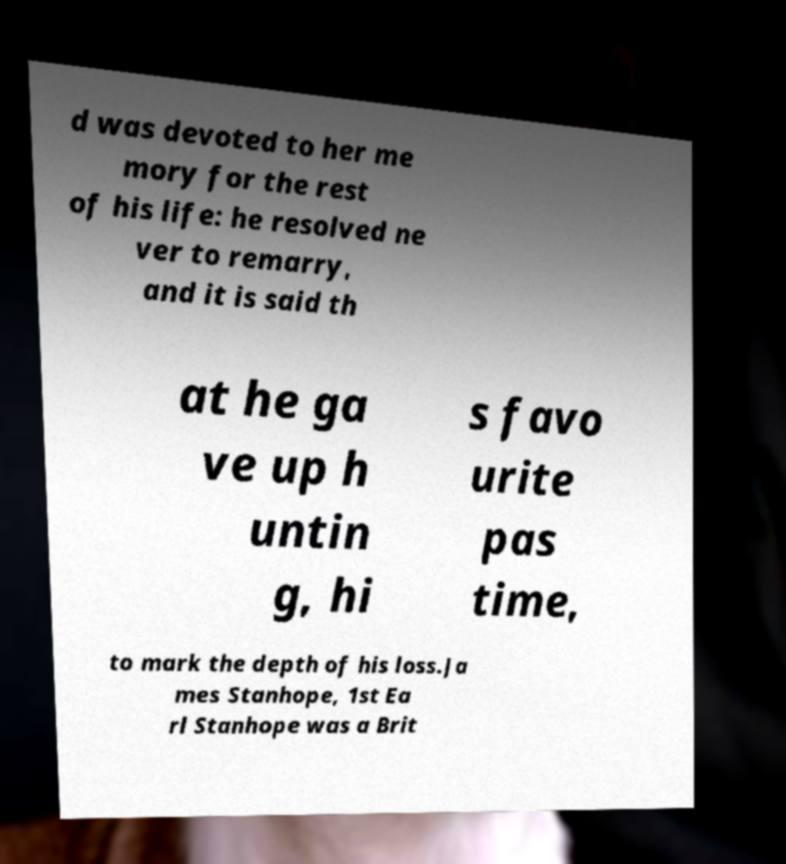For documentation purposes, I need the text within this image transcribed. Could you provide that? d was devoted to her me mory for the rest of his life: he resolved ne ver to remarry, and it is said th at he ga ve up h untin g, hi s favo urite pas time, to mark the depth of his loss.Ja mes Stanhope, 1st Ea rl Stanhope was a Brit 